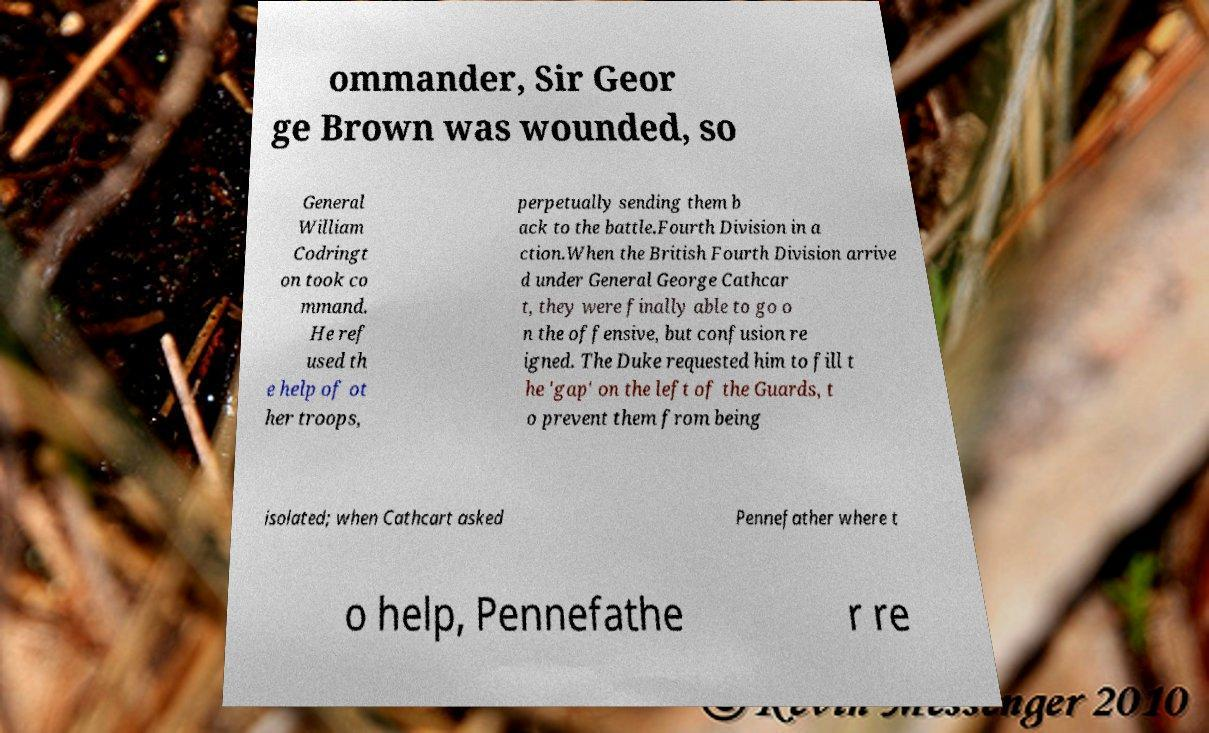For documentation purposes, I need the text within this image transcribed. Could you provide that? ommander, Sir Geor ge Brown was wounded, so General William Codringt on took co mmand. He ref used th e help of ot her troops, perpetually sending them b ack to the battle.Fourth Division in a ction.When the British Fourth Division arrive d under General George Cathcar t, they were finally able to go o n the offensive, but confusion re igned. The Duke requested him to fill t he 'gap' on the left of the Guards, t o prevent them from being isolated; when Cathcart asked Pennefather where t o help, Pennefathe r re 